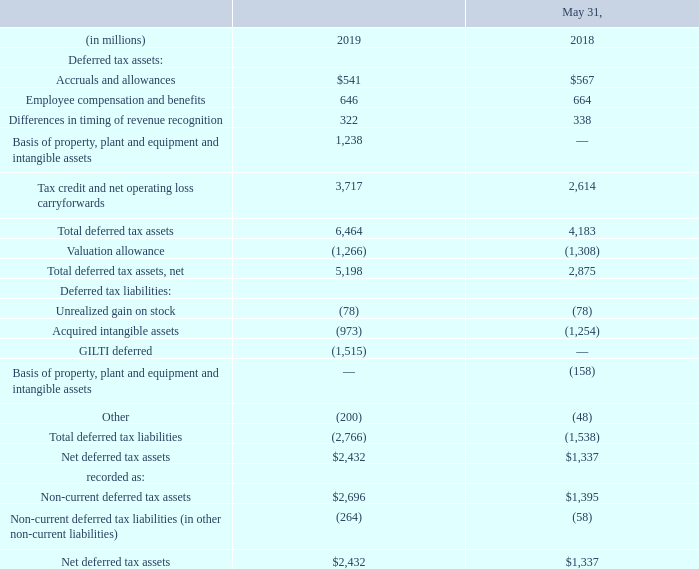The components of our deferred tax assets and liabilities were as follows:
We provide for taxes on the undistributed earnings of foreign subsidiaries. We do not provide for taxes on other outside basis temporary differences of foreign subsidiaries as they are considered indefinitely reinvested outside the U.S. At May 31, 2019, the amount of temporary differences related to other outside basis temporary differences of investments in foreign subsidiaries upon which U.S. income taxes have not been provided was approximately $7.9 billion. If the other outside basis differences were recognized in a taxable transaction, they would generate foreign tax credits that would reduce the federal tax liability associated with the foreign dividend or the otherwise taxable transaction. At May 31, 2019, assuming a full utilization of the foreign tax credits, the potential net deferred tax liability associated with these other outside basis temporary differences would be approximately $1.5 billion.
Our net deferred tax assets were $2.4 billion and $1.3 billion as of May 31, 2019 and 2018, respectively. We believe that it is more likely than not that the net deferred tax assets will be realized in the foreseeable future. realization of our net deferred tax assets is dependent upon our generation of sufficient taxable income in future years in appropriate tax jurisdictions to obtain benefit from the reversal of temporary differences, net operating loss carryforwards and tax credit carryforwards. The amount of net deferred tax assets considered realizable is subject to adjustment in future periods if estimates of future taxable income change.
The valuation allowance was $1.3 billion at each of May 31, 2019 and 2018. Substantially all of the valuation allowances as of May 31, 2019 and 2018 related to tax assets established in purchase accounting and other tax credits. Any subsequent reduction of that portion of the valuation allowance and the recognition of the associated tax benefits associated with our acquisitions will be recorded to our provision for income taxes subsequent to our final determination of the valuation allowance or the conclusion of the measurement period (as defined above), whichever comes first.
Why does Oracle not provide for taxes on other outside basis temporary differences of foreign subsidiaries? We do not provide for taxes on other outside basis temporary differences of foreign subsidiaries as they are considered indefinitely reinvested outside the u.s. What were the valuation allowances for 2019 related to? Substantially all of the valuation allowances as of may 31, 2019 and 2018 related to tax assets established in purchase accounting and other tax credits. What are the accruals and allowances for 2019?
Answer scale should be: million. $541. What is the total accruals and allowances for 2019 and 2018?
Answer scale should be: million. 541+567
Answer: 1108. What is the total employee compensation and benefits for 2019 and 2018?
Answer scale should be: million. 646+664
Answer: 1310. What was the % change in the net deferred tax assets from 2018 to 2019?
Answer scale should be: percent. (2,432-1,337)/1,337
Answer: 81.9. 